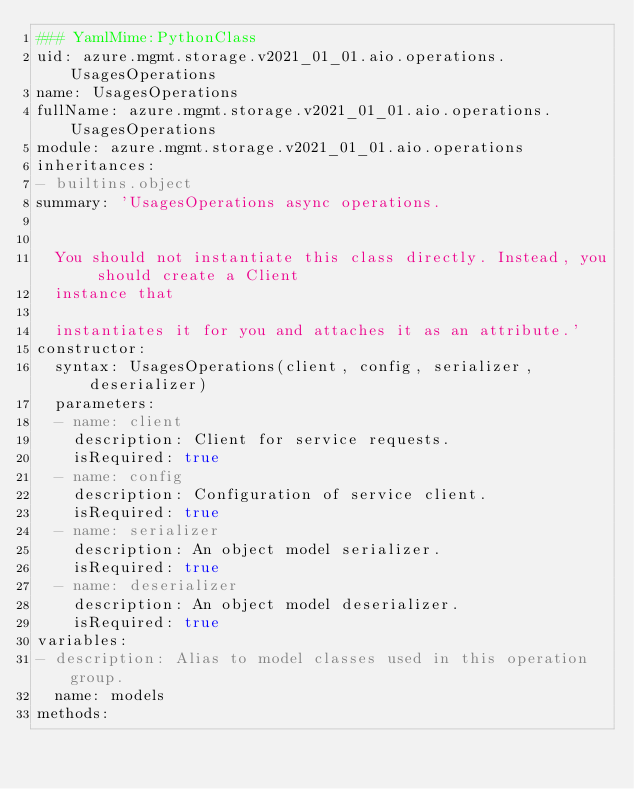Convert code to text. <code><loc_0><loc_0><loc_500><loc_500><_YAML_>### YamlMime:PythonClass
uid: azure.mgmt.storage.v2021_01_01.aio.operations.UsagesOperations
name: UsagesOperations
fullName: azure.mgmt.storage.v2021_01_01.aio.operations.UsagesOperations
module: azure.mgmt.storage.v2021_01_01.aio.operations
inheritances:
- builtins.object
summary: 'UsagesOperations async operations.


  You should not instantiate this class directly. Instead, you should create a Client
  instance that

  instantiates it for you and attaches it as an attribute.'
constructor:
  syntax: UsagesOperations(client, config, serializer, deserializer)
  parameters:
  - name: client
    description: Client for service requests.
    isRequired: true
  - name: config
    description: Configuration of service client.
    isRequired: true
  - name: serializer
    description: An object model serializer.
    isRequired: true
  - name: deserializer
    description: An object model deserializer.
    isRequired: true
variables:
- description: Alias to model classes used in this operation group.
  name: models
methods:</code> 